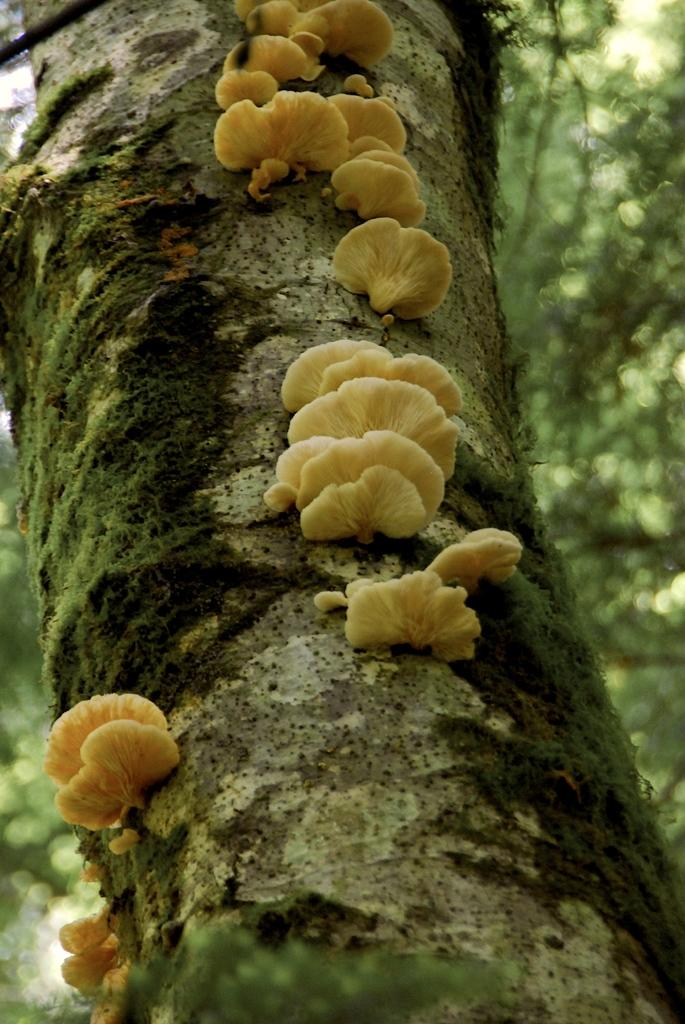What is the main subject of the image? The main subject of the image is a tree trunk. Are there any additional features on the tree trunk? Yes, there are mushrooms on the tree trunk. Can you describe the background of the image? The background of the image is blurry. What type of pancake is being served by the robin in the image? There is no robin or pancake present in the image. The image features a tree trunk with mushrooms, and the background is blurry. 